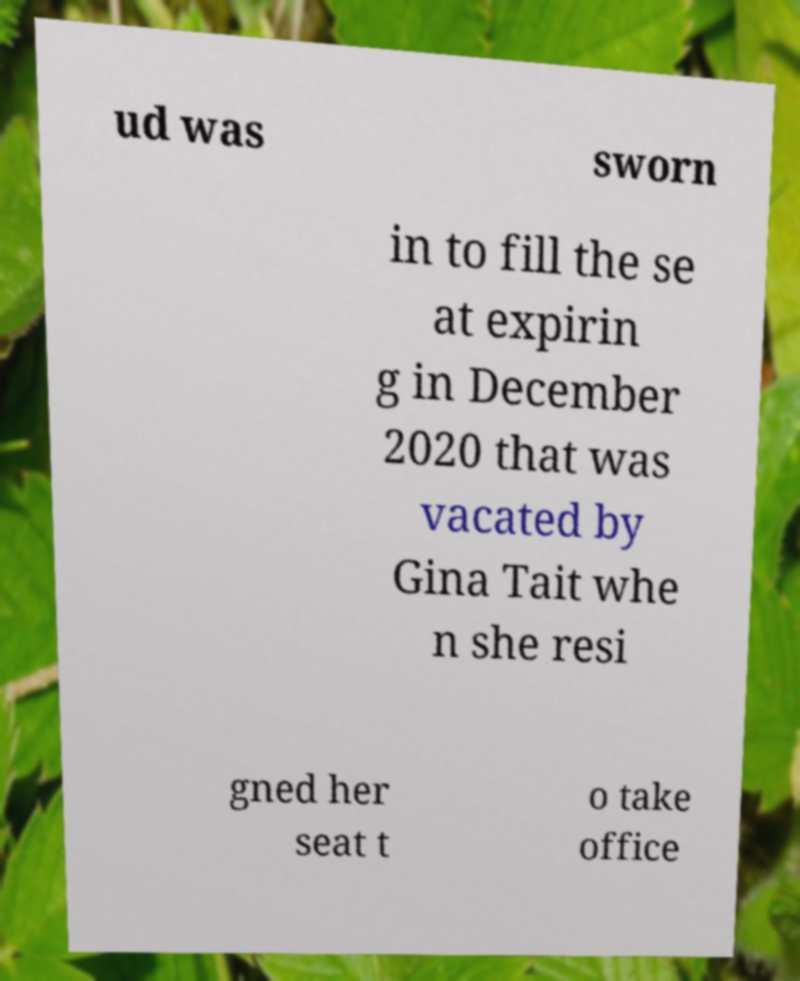For documentation purposes, I need the text within this image transcribed. Could you provide that? ud was sworn in to fill the se at expirin g in December 2020 that was vacated by Gina Tait whe n she resi gned her seat t o take office 